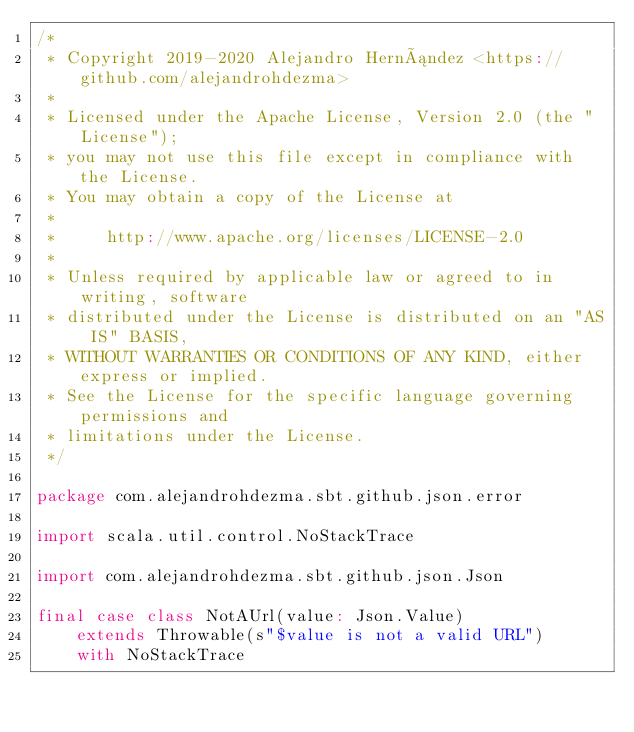Convert code to text. <code><loc_0><loc_0><loc_500><loc_500><_Scala_>/*
 * Copyright 2019-2020 Alejandro Hernández <https://github.com/alejandrohdezma>
 *
 * Licensed under the Apache License, Version 2.0 (the "License");
 * you may not use this file except in compliance with the License.
 * You may obtain a copy of the License at
 *
 *     http://www.apache.org/licenses/LICENSE-2.0
 *
 * Unless required by applicable law or agreed to in writing, software
 * distributed under the License is distributed on an "AS IS" BASIS,
 * WITHOUT WARRANTIES OR CONDITIONS OF ANY KIND, either express or implied.
 * See the License for the specific language governing permissions and
 * limitations under the License.
 */

package com.alejandrohdezma.sbt.github.json.error

import scala.util.control.NoStackTrace

import com.alejandrohdezma.sbt.github.json.Json

final case class NotAUrl(value: Json.Value)
    extends Throwable(s"$value is not a valid URL")
    with NoStackTrace
</code> 